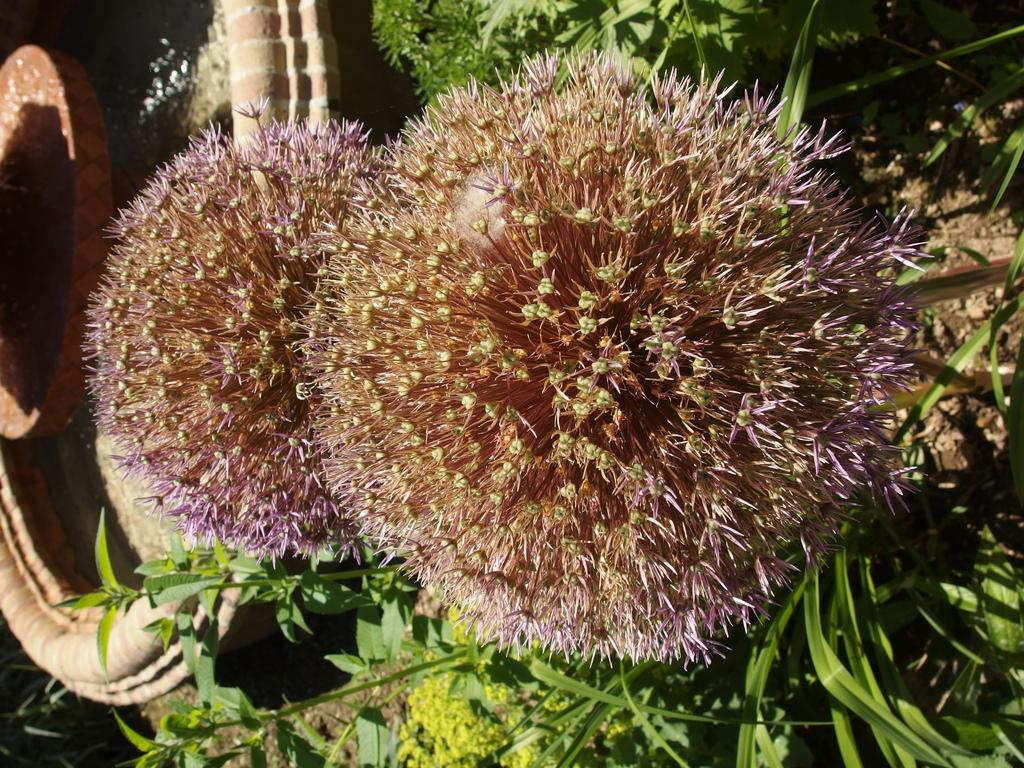What type of vegetation can be seen in the image? There are flowers, leaves, and plants in the image. Where is the water fountain located in the image? The water fountain is on the left side of the image. What is the water fountain doing in the image? Water is present in the water fountain. What type of chance game is being played in the image? There is no chance game present in the image; it features flowers, leaves, plants, and a water fountain. Can you tell me how many ears of corn are visible in the image? There are no ears of corn present in the image. 